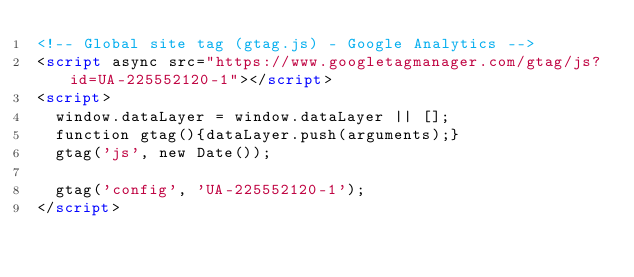<code> <loc_0><loc_0><loc_500><loc_500><_HTML_><!-- Global site tag (gtag.js) - Google Analytics -->
<script async src="https://www.googletagmanager.com/gtag/js?id=UA-225552120-1"></script>
<script>
  window.dataLayer = window.dataLayer || [];
  function gtag(){dataLayer.push(arguments);}
  gtag('js', new Date());

  gtag('config', 'UA-225552120-1');
</script>
</code> 